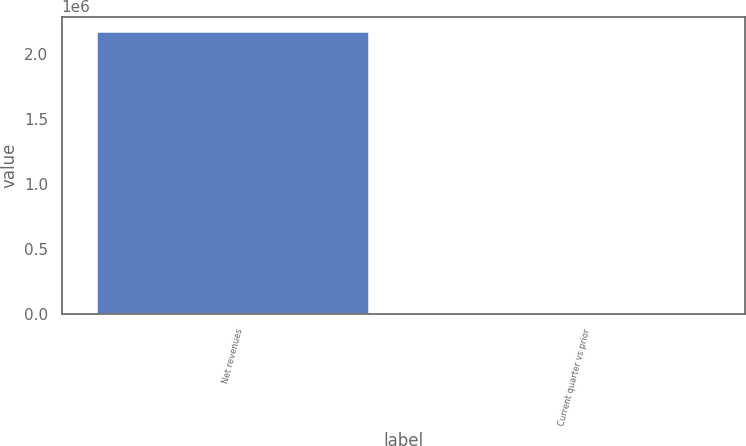Convert chart to OTSL. <chart><loc_0><loc_0><loc_500><loc_500><bar_chart><fcel>Net revenues<fcel>Current quarter vs prior<nl><fcel>2.18061e+06<fcel>15<nl></chart> 